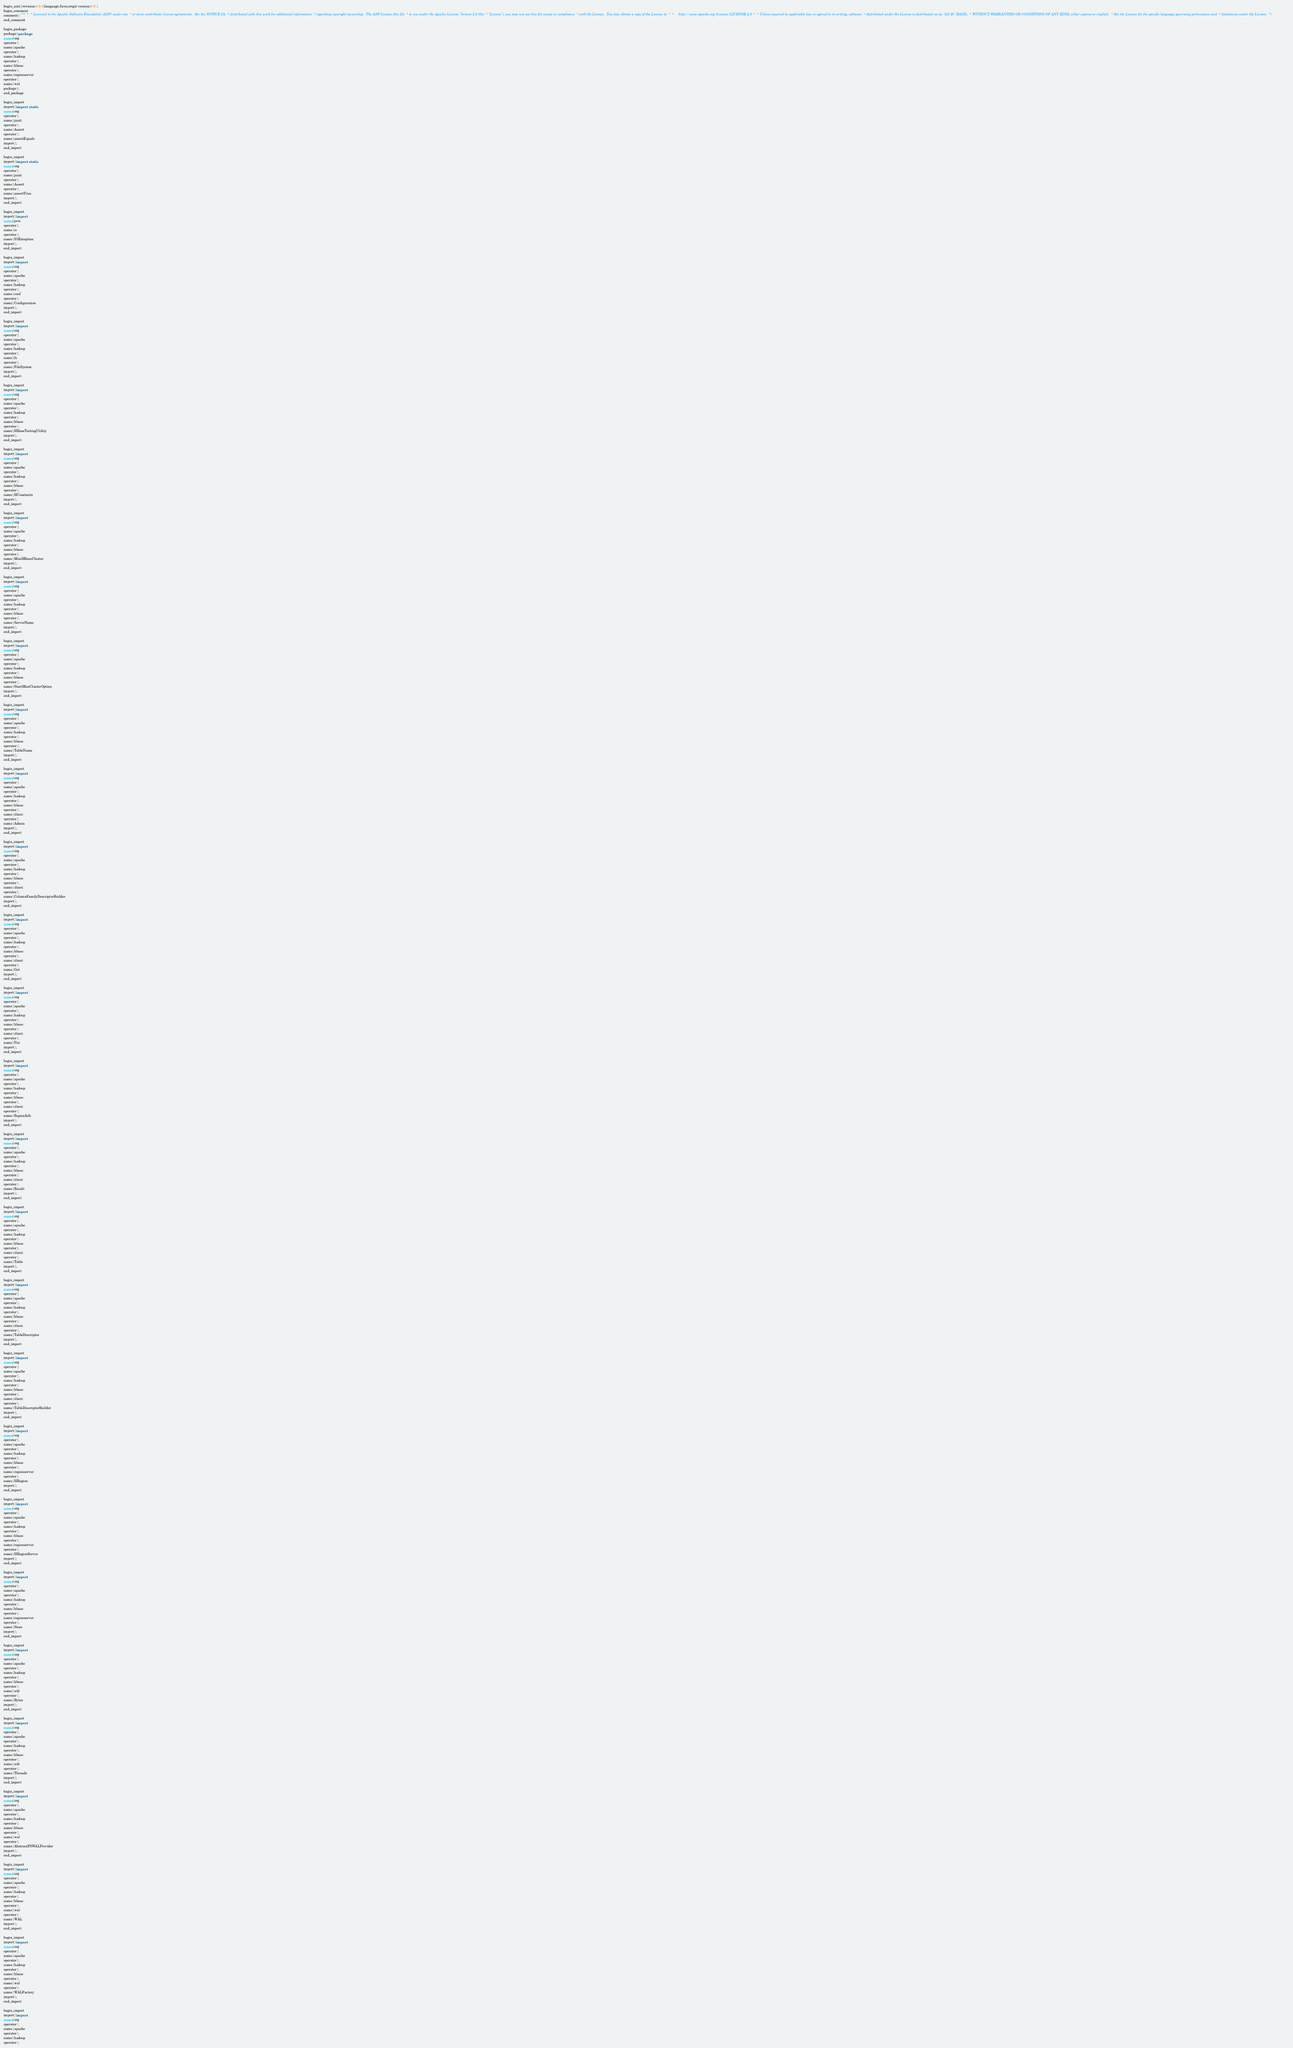<code> <loc_0><loc_0><loc_500><loc_500><_Java_>begin_unit|revision:0.9.5;language:Java;cregit-version:0.0.1
begin_comment
comment|/**  *  * Licensed to the Apache Software Foundation (ASF) under one  * or more contributor license agreements.  See the NOTICE file  * distributed with this work for additional information  * regarding copyright ownership.  The ASF licenses this file  * to you under the Apache License, Version 2.0 (the  * "License"); you may not use this file except in compliance  * with the License.  You may obtain a copy of the License at  *  *     http://www.apache.org/licenses/LICENSE-2.0  *  * Unless required by applicable law or agreed to in writing, software  * distributed under the License is distributed on an "AS IS" BASIS,  * WITHOUT WARRANTIES OR CONDITIONS OF ANY KIND, either express or implied.  * See the License for the specific language governing permissions and  * limitations under the License.  */
end_comment

begin_package
package|package
name|org
operator|.
name|apache
operator|.
name|hadoop
operator|.
name|hbase
operator|.
name|regionserver
operator|.
name|wal
package|;
end_package

begin_import
import|import static
name|org
operator|.
name|junit
operator|.
name|Assert
operator|.
name|assertEquals
import|;
end_import

begin_import
import|import static
name|org
operator|.
name|junit
operator|.
name|Assert
operator|.
name|assertTrue
import|;
end_import

begin_import
import|import
name|java
operator|.
name|io
operator|.
name|IOException
import|;
end_import

begin_import
import|import
name|org
operator|.
name|apache
operator|.
name|hadoop
operator|.
name|conf
operator|.
name|Configuration
import|;
end_import

begin_import
import|import
name|org
operator|.
name|apache
operator|.
name|hadoop
operator|.
name|fs
operator|.
name|FileSystem
import|;
end_import

begin_import
import|import
name|org
operator|.
name|apache
operator|.
name|hadoop
operator|.
name|hbase
operator|.
name|HBaseTestingUtility
import|;
end_import

begin_import
import|import
name|org
operator|.
name|apache
operator|.
name|hadoop
operator|.
name|hbase
operator|.
name|HConstants
import|;
end_import

begin_import
import|import
name|org
operator|.
name|apache
operator|.
name|hadoop
operator|.
name|hbase
operator|.
name|MiniHBaseCluster
import|;
end_import

begin_import
import|import
name|org
operator|.
name|apache
operator|.
name|hadoop
operator|.
name|hbase
operator|.
name|ServerName
import|;
end_import

begin_import
import|import
name|org
operator|.
name|apache
operator|.
name|hadoop
operator|.
name|hbase
operator|.
name|StartMiniClusterOption
import|;
end_import

begin_import
import|import
name|org
operator|.
name|apache
operator|.
name|hadoop
operator|.
name|hbase
operator|.
name|TableName
import|;
end_import

begin_import
import|import
name|org
operator|.
name|apache
operator|.
name|hadoop
operator|.
name|hbase
operator|.
name|client
operator|.
name|Admin
import|;
end_import

begin_import
import|import
name|org
operator|.
name|apache
operator|.
name|hadoop
operator|.
name|hbase
operator|.
name|client
operator|.
name|ColumnFamilyDescriptorBuilder
import|;
end_import

begin_import
import|import
name|org
operator|.
name|apache
operator|.
name|hadoop
operator|.
name|hbase
operator|.
name|client
operator|.
name|Get
import|;
end_import

begin_import
import|import
name|org
operator|.
name|apache
operator|.
name|hadoop
operator|.
name|hbase
operator|.
name|client
operator|.
name|Put
import|;
end_import

begin_import
import|import
name|org
operator|.
name|apache
operator|.
name|hadoop
operator|.
name|hbase
operator|.
name|client
operator|.
name|RegionInfo
import|;
end_import

begin_import
import|import
name|org
operator|.
name|apache
operator|.
name|hadoop
operator|.
name|hbase
operator|.
name|client
operator|.
name|Result
import|;
end_import

begin_import
import|import
name|org
operator|.
name|apache
operator|.
name|hadoop
operator|.
name|hbase
operator|.
name|client
operator|.
name|Table
import|;
end_import

begin_import
import|import
name|org
operator|.
name|apache
operator|.
name|hadoop
operator|.
name|hbase
operator|.
name|client
operator|.
name|TableDescriptor
import|;
end_import

begin_import
import|import
name|org
operator|.
name|apache
operator|.
name|hadoop
operator|.
name|hbase
operator|.
name|client
operator|.
name|TableDescriptorBuilder
import|;
end_import

begin_import
import|import
name|org
operator|.
name|apache
operator|.
name|hadoop
operator|.
name|hbase
operator|.
name|regionserver
operator|.
name|HRegion
import|;
end_import

begin_import
import|import
name|org
operator|.
name|apache
operator|.
name|hadoop
operator|.
name|hbase
operator|.
name|regionserver
operator|.
name|HRegionServer
import|;
end_import

begin_import
import|import
name|org
operator|.
name|apache
operator|.
name|hadoop
operator|.
name|hbase
operator|.
name|regionserver
operator|.
name|Store
import|;
end_import

begin_import
import|import
name|org
operator|.
name|apache
operator|.
name|hadoop
operator|.
name|hbase
operator|.
name|util
operator|.
name|Bytes
import|;
end_import

begin_import
import|import
name|org
operator|.
name|apache
operator|.
name|hadoop
operator|.
name|hbase
operator|.
name|util
operator|.
name|Threads
import|;
end_import

begin_import
import|import
name|org
operator|.
name|apache
operator|.
name|hadoop
operator|.
name|hbase
operator|.
name|wal
operator|.
name|AbstractFSWALProvider
import|;
end_import

begin_import
import|import
name|org
operator|.
name|apache
operator|.
name|hadoop
operator|.
name|hbase
operator|.
name|wal
operator|.
name|WAL
import|;
end_import

begin_import
import|import
name|org
operator|.
name|apache
operator|.
name|hadoop
operator|.
name|hbase
operator|.
name|wal
operator|.
name|WALFactory
import|;
end_import

begin_import
import|import
name|org
operator|.
name|apache
operator|.
name|hadoop
operator|.</code> 